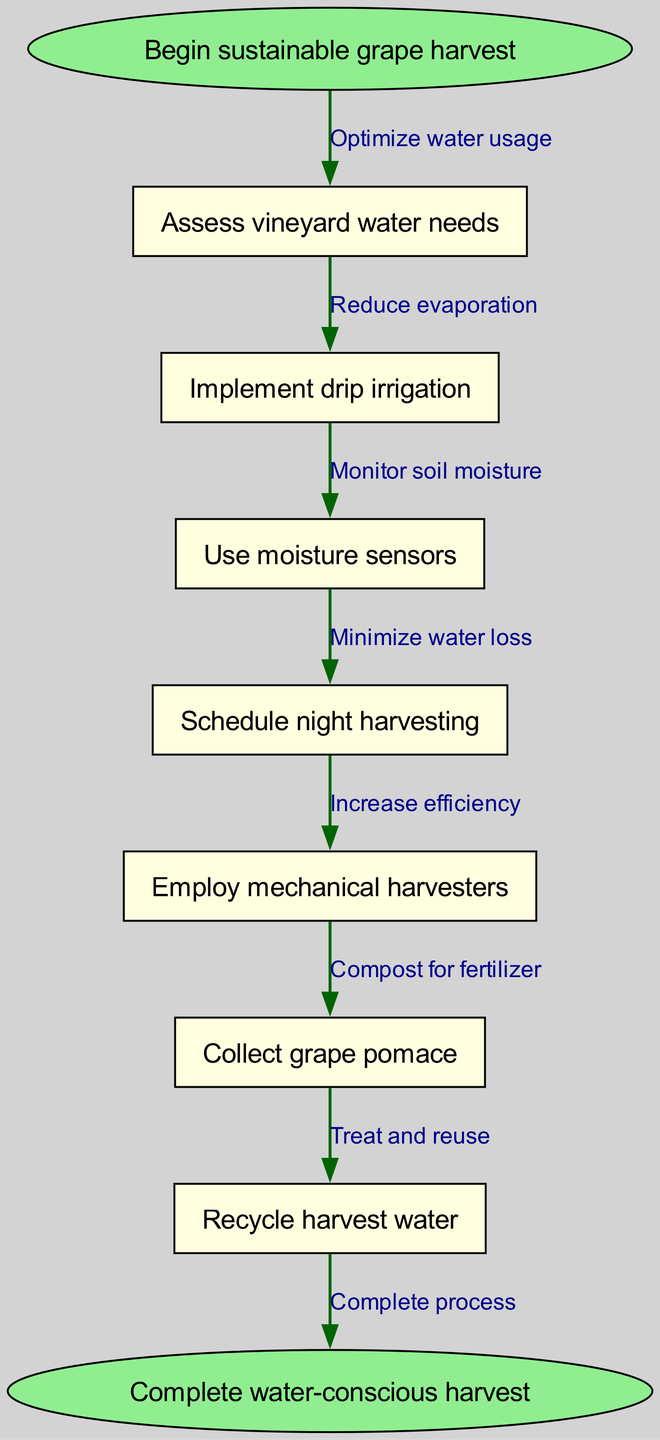What is the first step in the process? The diagram starts with the node labeled "Begin sustainable grape harvest," representing the initial action in the process of sustainable grape harvesting.
Answer: Begin sustainable grape harvest How many nodes are in the diagram? By counting the nodes listed in the diagram, there are a total of seven process nodes plus the start and end nodes, making it a total of nine nodes.
Answer: Nine Which step follows "Implement drip irrigation"? The flow from "Implement drip irrigation" leads directly to the next step labeled "Use moisture sensors." This shows the sequence of operations in the process.
Answer: Use moisture sensors What is the purpose of employing "mechanical harvesters"? The diagram indicates that employing mechanical harvesters is aimed at "Increase efficiency," highlighting the goal of this step in the overall harvesting process.
Answer: Increase efficiency What is the last step in the process? The final step in the flow chart, leading from the last process node, is labeled "Complete water-conscious harvest," which indicates the conclusion of the sustainable grape harvesting process.
Answer: Complete water-conscious harvest How does "Schedule night harvesting" help the process? The relationship in the diagram states that scheduling night harvesting is intended to "Reduce evaporation," which means it serves a critical role in maintaining water conservation.
Answer: Reduce evaporation What is connected to "Collect grape pomace"? The edge from "Collect grape pomace" connects to "Compost for fertilizer," indicating that this step is related to recycling waste materials into fertilizer.
Answer: Compost for fertilizer What is the relationship between "Recycle harvest water" and its preceding step? The preceding step is "Employ mechanical harvesters," and the edge indicates that the relationship is "Treat and reuse," connecting the actions of using harvested water efficiently to the mechanical process.
Answer: Treat and reuse 